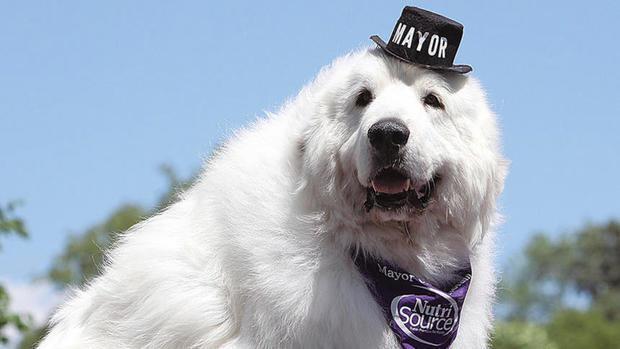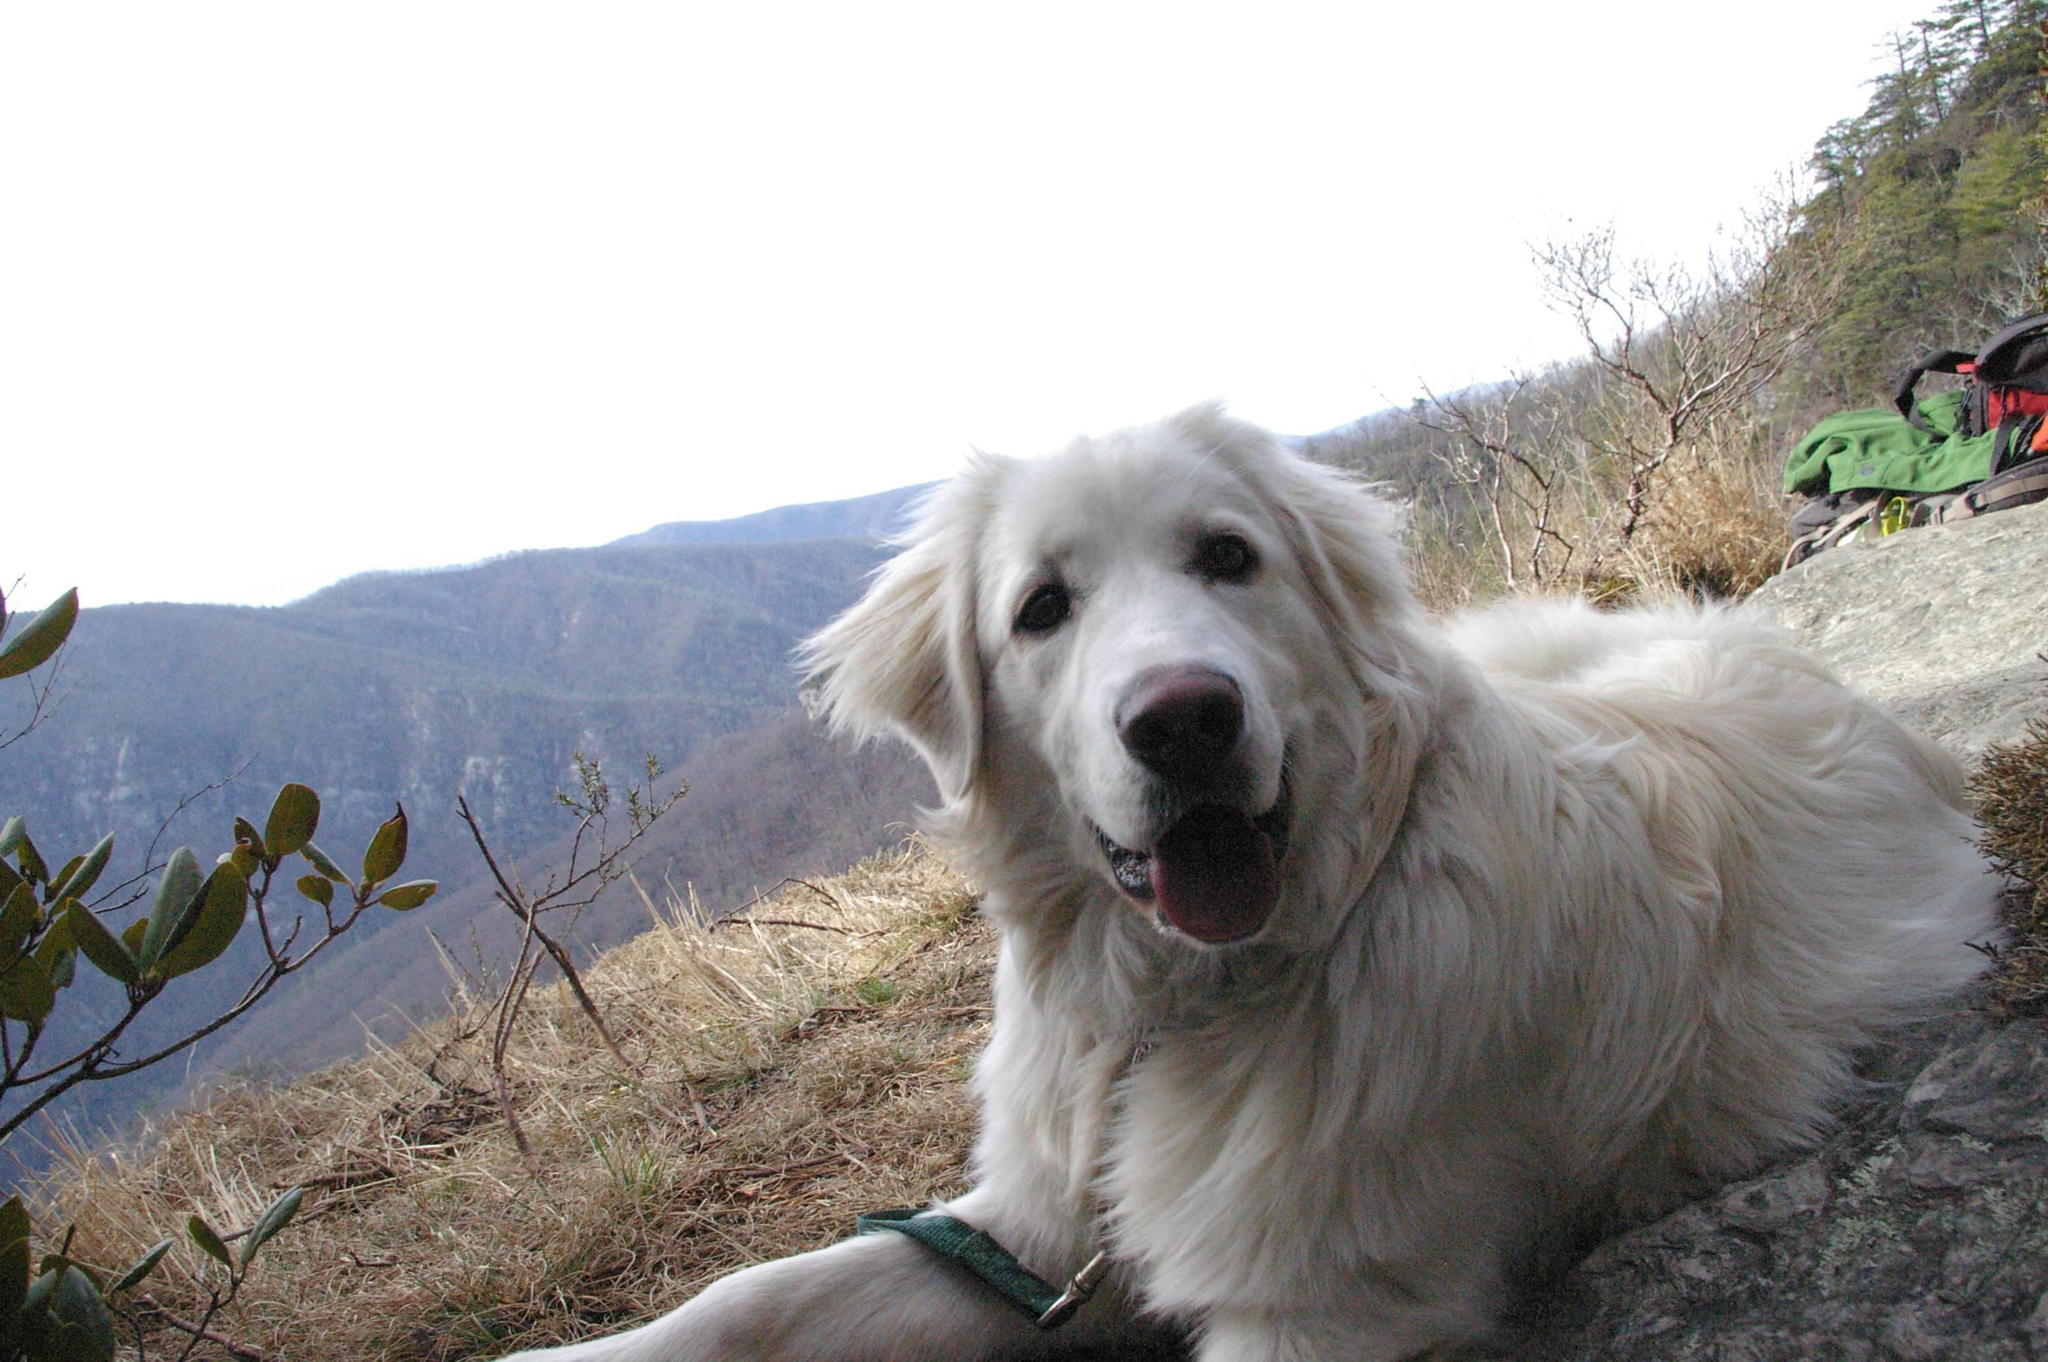The first image is the image on the left, the second image is the image on the right. Analyze the images presented: Is the assertion "the right image has mountains in the background" valid? Answer yes or no. Yes. 